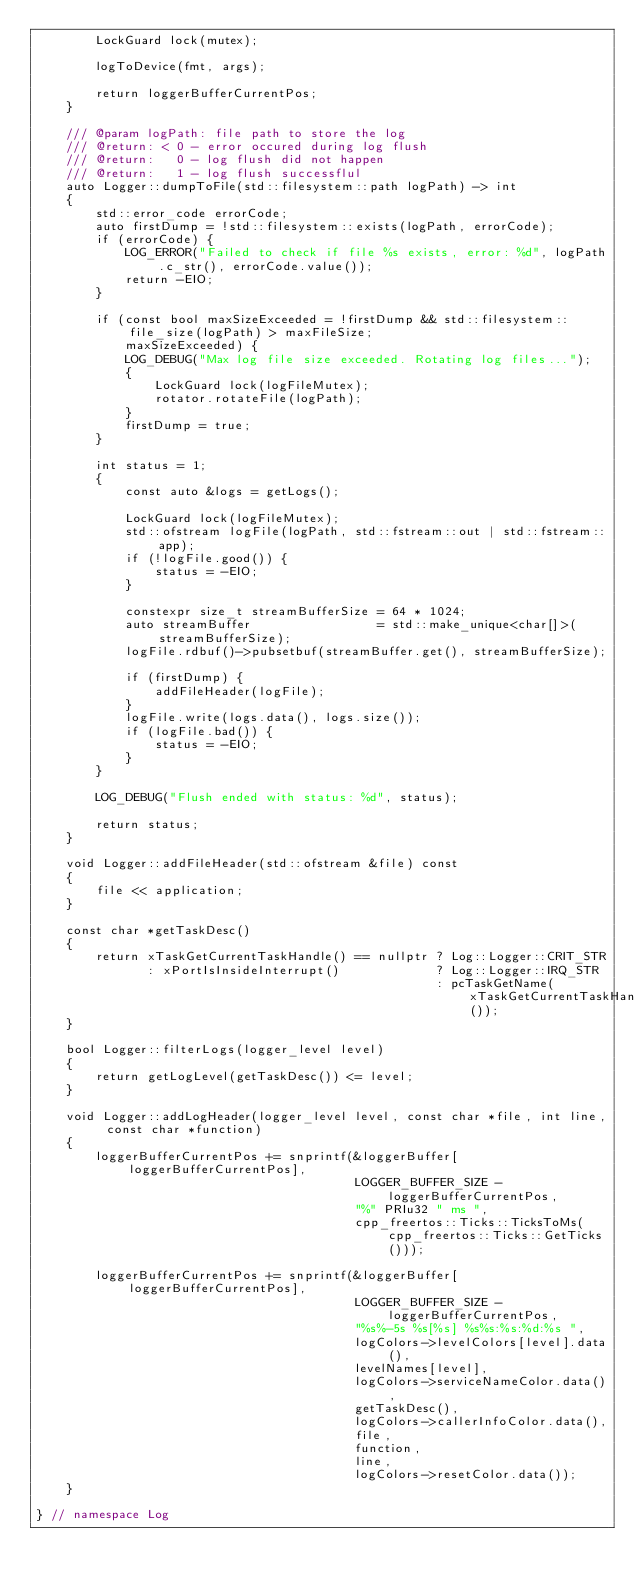Convert code to text. <code><loc_0><loc_0><loc_500><loc_500><_C++_>        LockGuard lock(mutex);

        logToDevice(fmt, args);

        return loggerBufferCurrentPos;
    }

    /// @param logPath: file path to store the log
    /// @return: < 0 - error occured during log flush
    /// @return:   0 - log flush did not happen
    /// @return:   1 - log flush successflul
    auto Logger::dumpToFile(std::filesystem::path logPath) -> int
    {
        std::error_code errorCode;
        auto firstDump = !std::filesystem::exists(logPath, errorCode);
        if (errorCode) {
            LOG_ERROR("Failed to check if file %s exists, error: %d", logPath.c_str(), errorCode.value());
            return -EIO;
        }

        if (const bool maxSizeExceeded = !firstDump && std::filesystem::file_size(logPath) > maxFileSize;
            maxSizeExceeded) {
            LOG_DEBUG("Max log file size exceeded. Rotating log files...");
            {
                LockGuard lock(logFileMutex);
                rotator.rotateFile(logPath);
            }
            firstDump = true;
        }

        int status = 1;
        {
            const auto &logs = getLogs();

            LockGuard lock(logFileMutex);
            std::ofstream logFile(logPath, std::fstream::out | std::fstream::app);
            if (!logFile.good()) {
                status = -EIO;
            }

            constexpr size_t streamBufferSize = 64 * 1024;
            auto streamBuffer                 = std::make_unique<char[]>(streamBufferSize);
            logFile.rdbuf()->pubsetbuf(streamBuffer.get(), streamBufferSize);

            if (firstDump) {
                addFileHeader(logFile);
            }
            logFile.write(logs.data(), logs.size());
            if (logFile.bad()) {
                status = -EIO;
            }
        }

        LOG_DEBUG("Flush ended with status: %d", status);

        return status;
    }

    void Logger::addFileHeader(std::ofstream &file) const
    {
        file << application;
    }

    const char *getTaskDesc()
    {
        return xTaskGetCurrentTaskHandle() == nullptr ? Log::Logger::CRIT_STR
               : xPortIsInsideInterrupt()             ? Log::Logger::IRQ_STR
                                                      : pcTaskGetName(xTaskGetCurrentTaskHandle());
    }

    bool Logger::filterLogs(logger_level level)
    {
        return getLogLevel(getTaskDesc()) <= level;
    }

    void Logger::addLogHeader(logger_level level, const char *file, int line, const char *function)
    {
        loggerBufferCurrentPos += snprintf(&loggerBuffer[loggerBufferCurrentPos],
                                           LOGGER_BUFFER_SIZE - loggerBufferCurrentPos,
                                           "%" PRIu32 " ms ",
                                           cpp_freertos::Ticks::TicksToMs(cpp_freertos::Ticks::GetTicks()));

        loggerBufferCurrentPos += snprintf(&loggerBuffer[loggerBufferCurrentPos],
                                           LOGGER_BUFFER_SIZE - loggerBufferCurrentPos,
                                           "%s%-5s %s[%s] %s%s:%s:%d:%s ",
                                           logColors->levelColors[level].data(),
                                           levelNames[level],
                                           logColors->serviceNameColor.data(),
                                           getTaskDesc(),
                                           logColors->callerInfoColor.data(),
                                           file,
                                           function,
                                           line,
                                           logColors->resetColor.data());
    }

} // namespace Log
</code> 